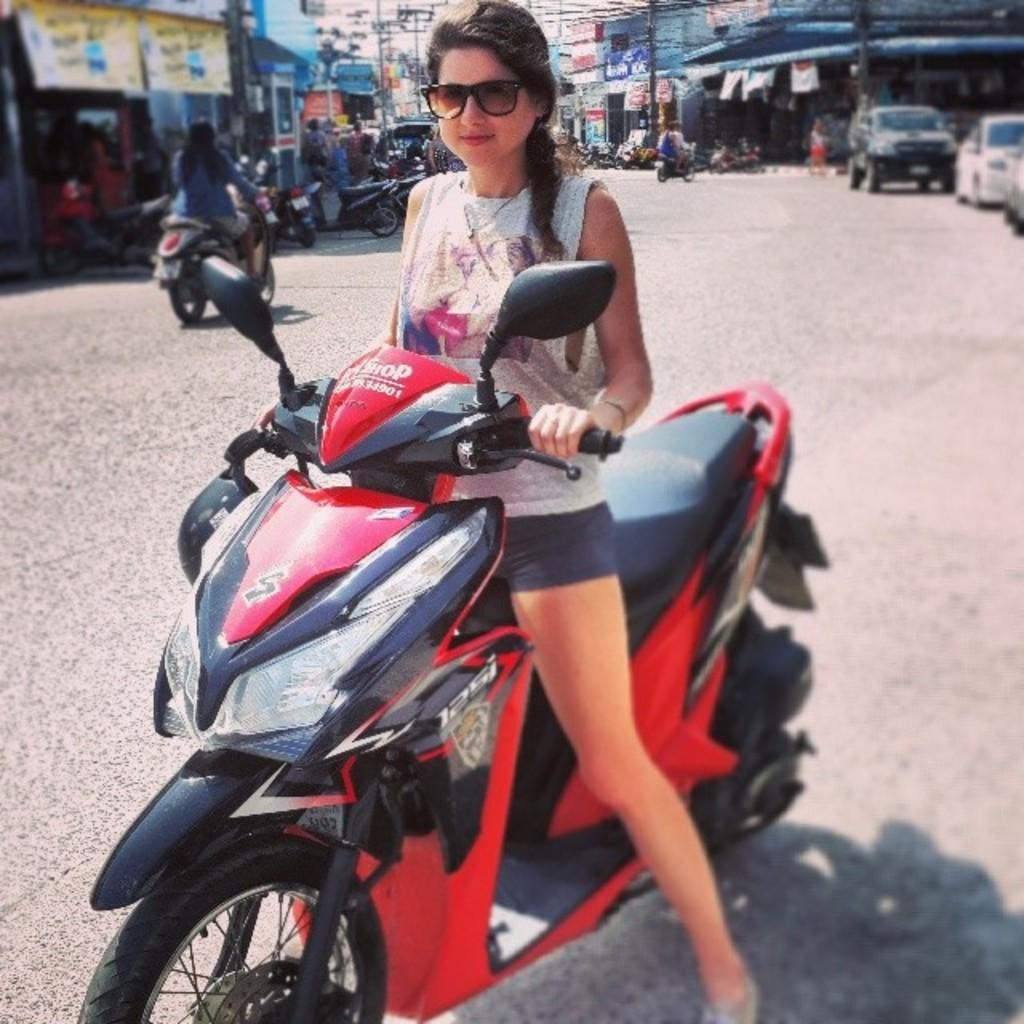What is the woman doing in the image? The woman is sitting on a scooty in the image. What are other people doing in the image? People are sitting on the back of bikes in the image. What types of vehicles are present in the image? Vehicles, including bikes and scooty, are present in the image. What is the position of the cars in the image? Cars are parked at the back in the image. What type of voice can be heard coming from the person sitting on the back of a bike in the image? There is no indication of any sound or voice in the image, as it is a still photograph. 